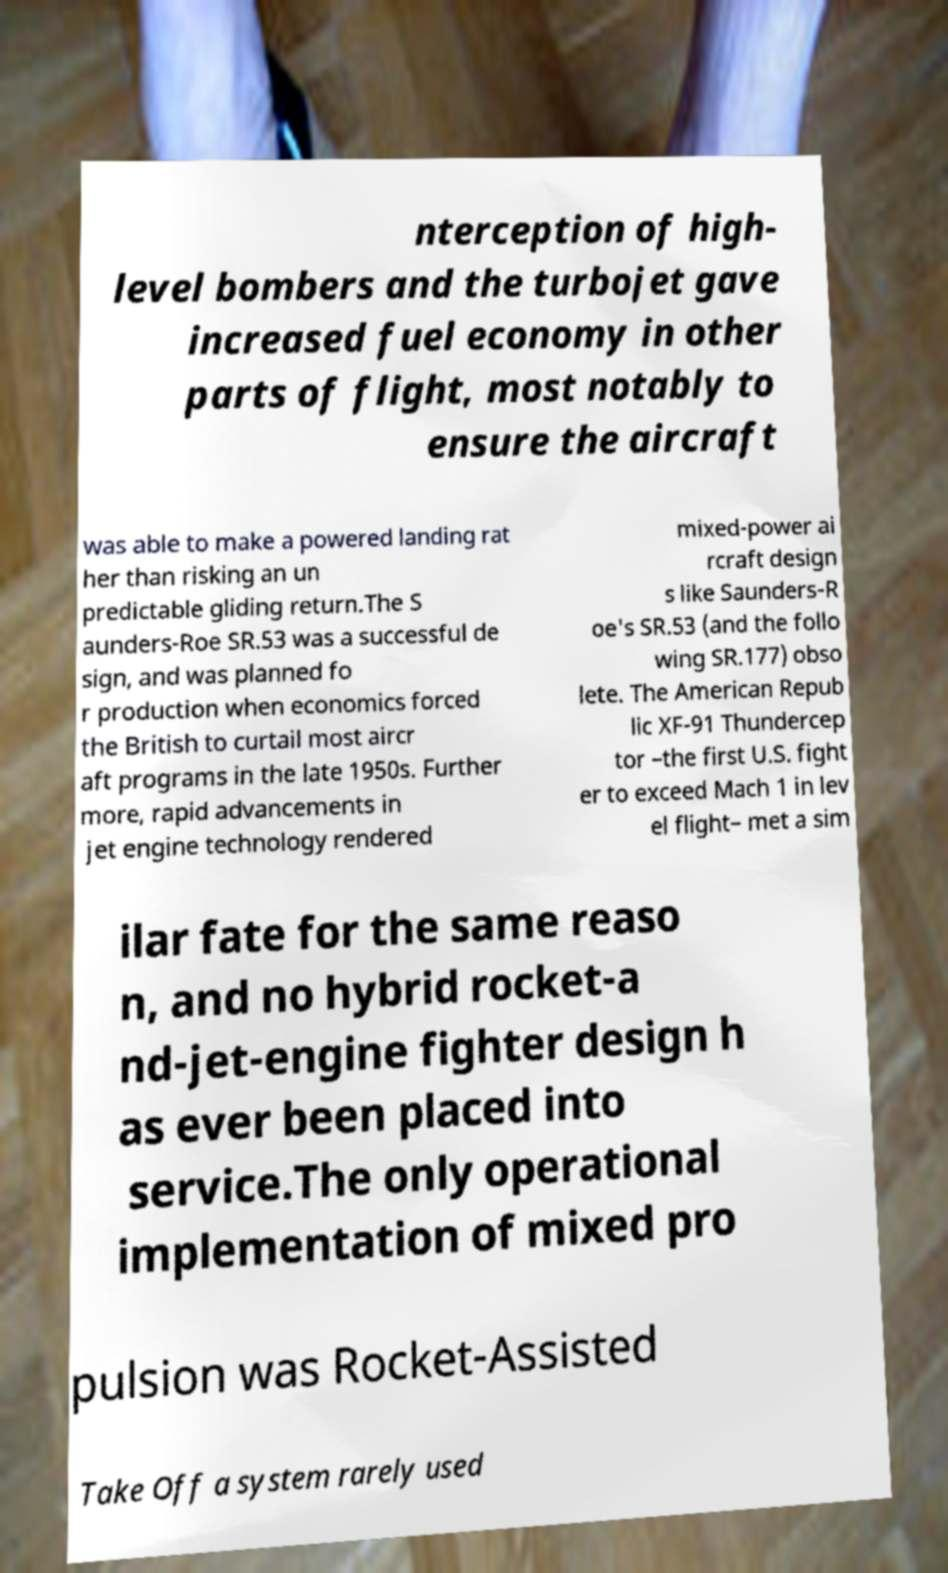Please identify and transcribe the text found in this image. nterception of high- level bombers and the turbojet gave increased fuel economy in other parts of flight, most notably to ensure the aircraft was able to make a powered landing rat her than risking an un predictable gliding return.The S aunders-Roe SR.53 was a successful de sign, and was planned fo r production when economics forced the British to curtail most aircr aft programs in the late 1950s. Further more, rapid advancements in jet engine technology rendered mixed-power ai rcraft design s like Saunders-R oe's SR.53 (and the follo wing SR.177) obso lete. The American Repub lic XF-91 Thundercep tor –the first U.S. fight er to exceed Mach 1 in lev el flight– met a sim ilar fate for the same reaso n, and no hybrid rocket-a nd-jet-engine fighter design h as ever been placed into service.The only operational implementation of mixed pro pulsion was Rocket-Assisted Take Off a system rarely used 